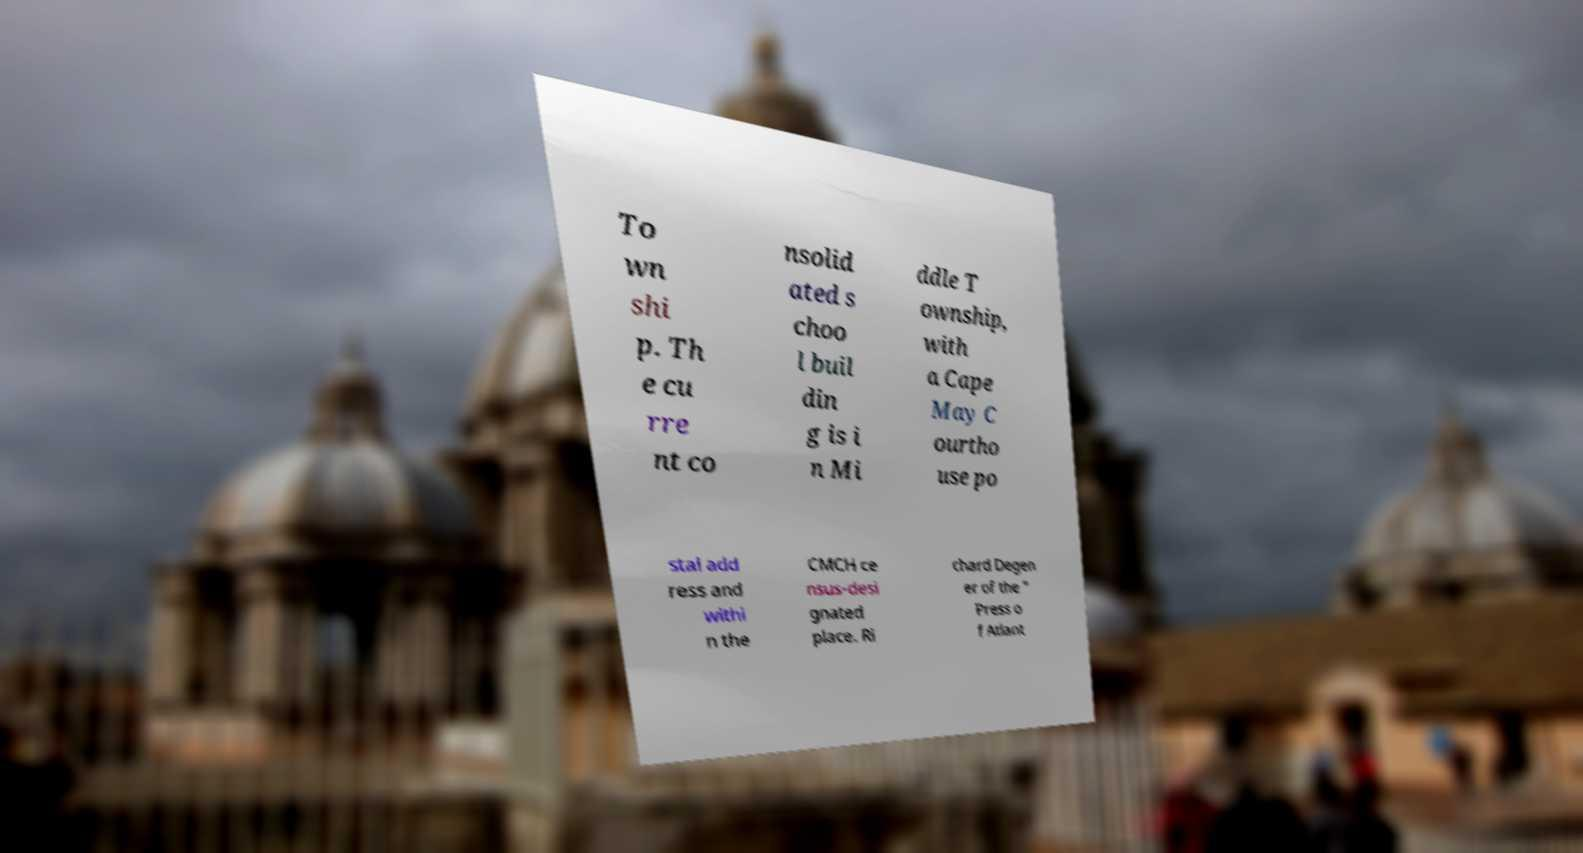Please identify and transcribe the text found in this image. To wn shi p. Th e cu rre nt co nsolid ated s choo l buil din g is i n Mi ddle T ownship, with a Cape May C ourtho use po stal add ress and withi n the CMCH ce nsus-desi gnated place. Ri chard Degen er of the " Press o f Atlant 